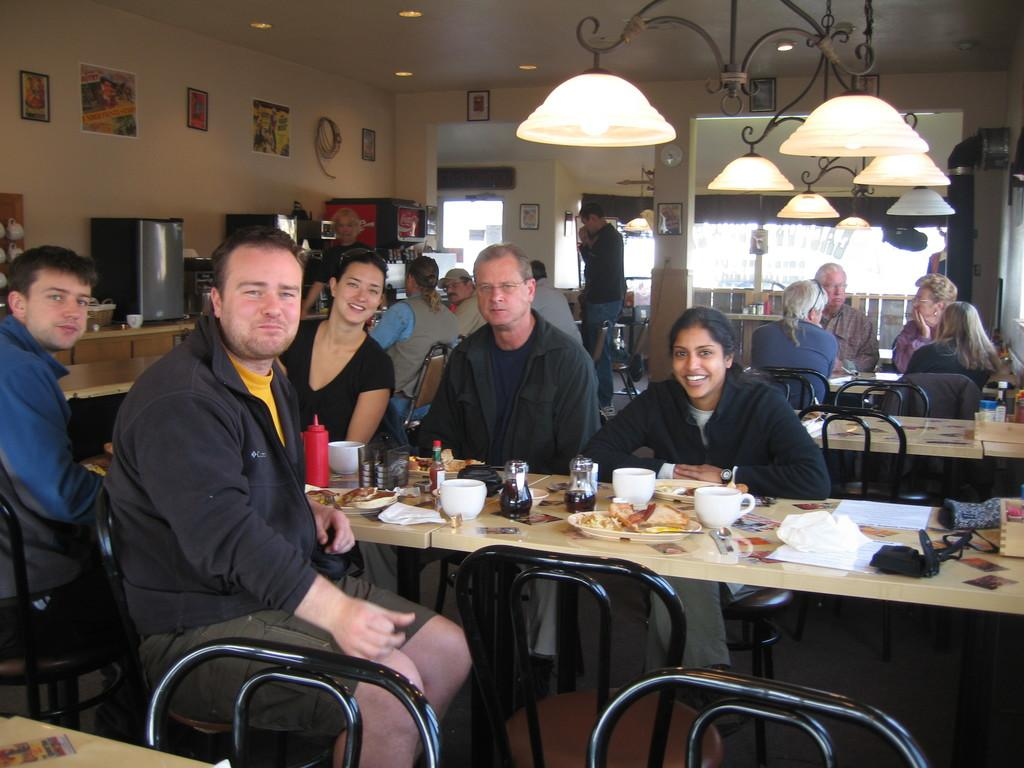What are the people in the image doing? The people in the image are sitting. What is in front of the people? There is a table in front of the people. What is on the table? There is a bowl and a ketchup bottle on the table. What else can be seen on the table? There are food items on a plate on the table. How does the group of people control the flock of birds in the image? There are no birds present in the image, and the people are not controlling any flock. 